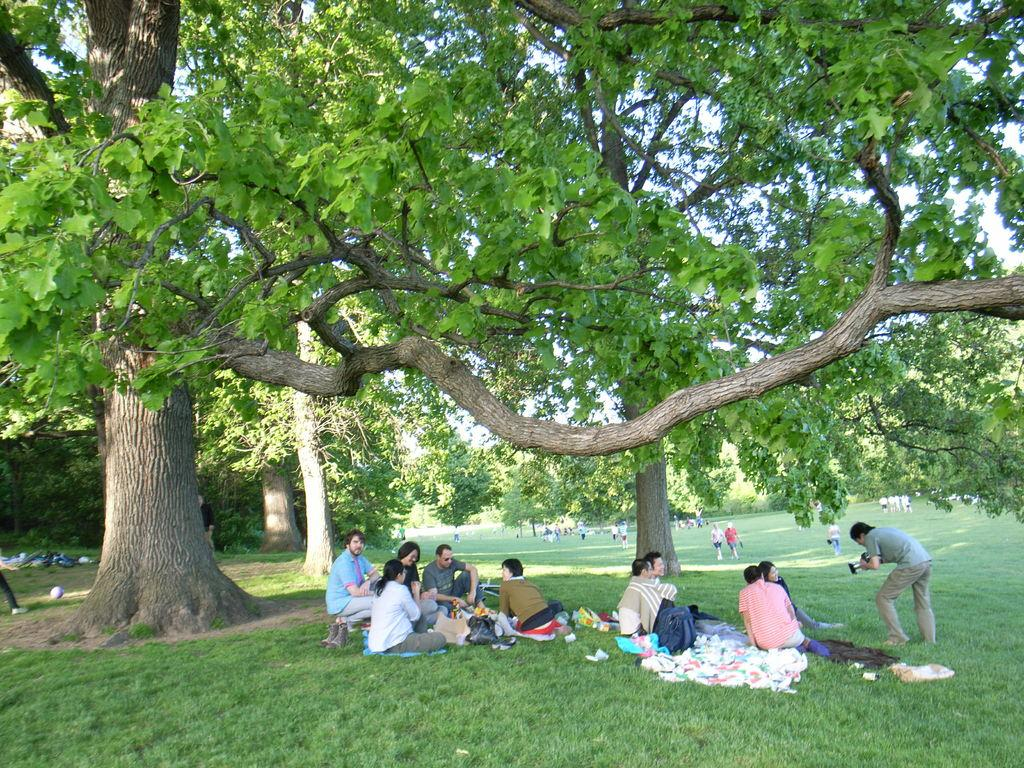What type of vegetation can be seen in the image? There is grass in the image. What are the people doing on the grass? There are people on the grass, but their specific activities are not mentioned in the facts. What other natural elements are present in the image? There are trees in the image. What can be seen in the distance in the image? The sky is visible in the background of the image. What flavor of ice cream are the people on the grass enjoying in the image? There is no mention of ice cream or any food in the image, so we cannot determine the flavor of any ice cream. 